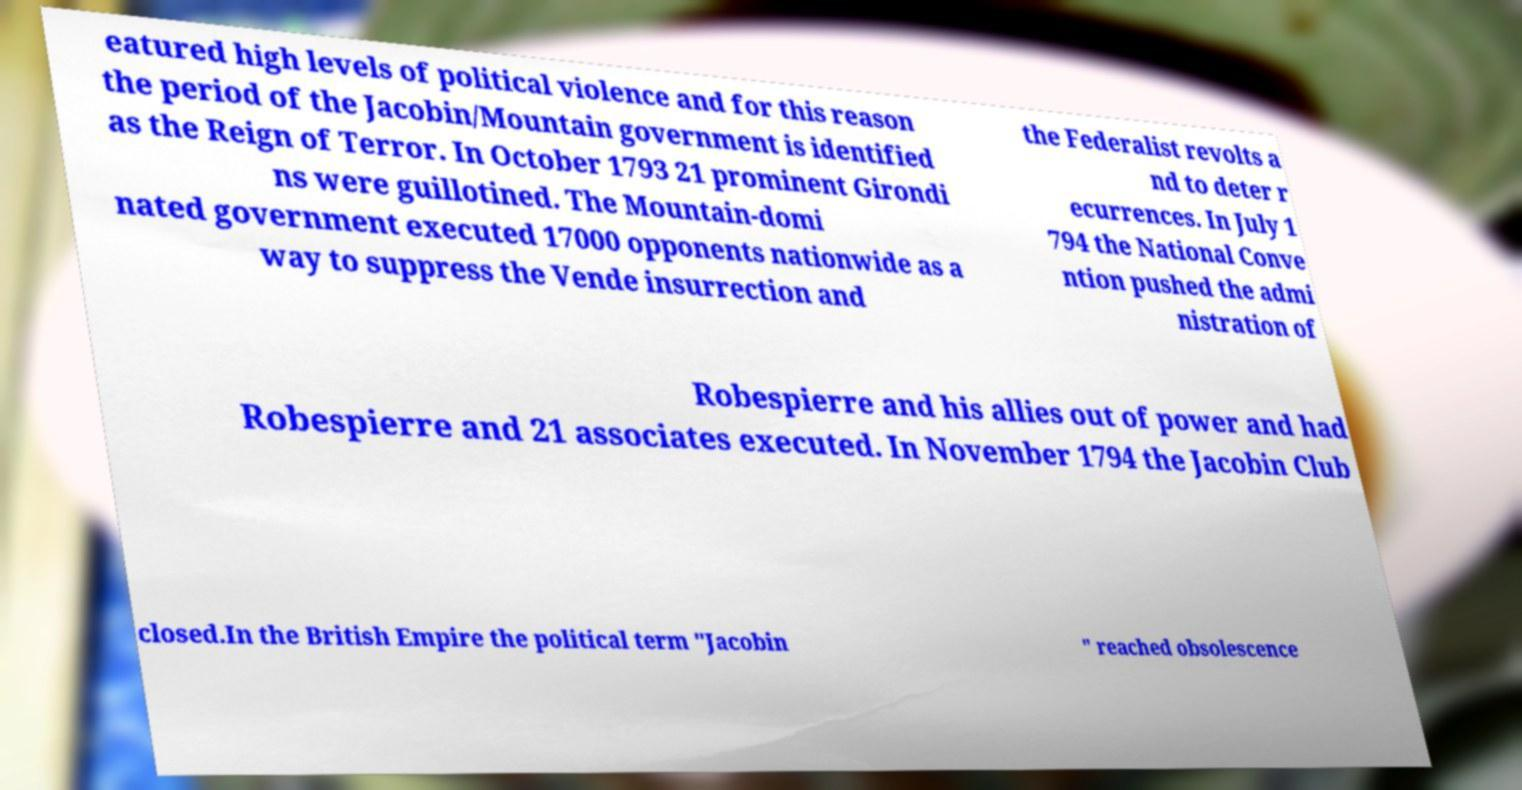Please identify and transcribe the text found in this image. eatured high levels of political violence and for this reason the period of the Jacobin/Mountain government is identified as the Reign of Terror. In October 1793 21 prominent Girondi ns were guillotined. The Mountain-domi nated government executed 17000 opponents nationwide as a way to suppress the Vende insurrection and the Federalist revolts a nd to deter r ecurrences. In July 1 794 the National Conve ntion pushed the admi nistration of Robespierre and his allies out of power and had Robespierre and 21 associates executed. In November 1794 the Jacobin Club closed.In the British Empire the political term "Jacobin " reached obsolescence 